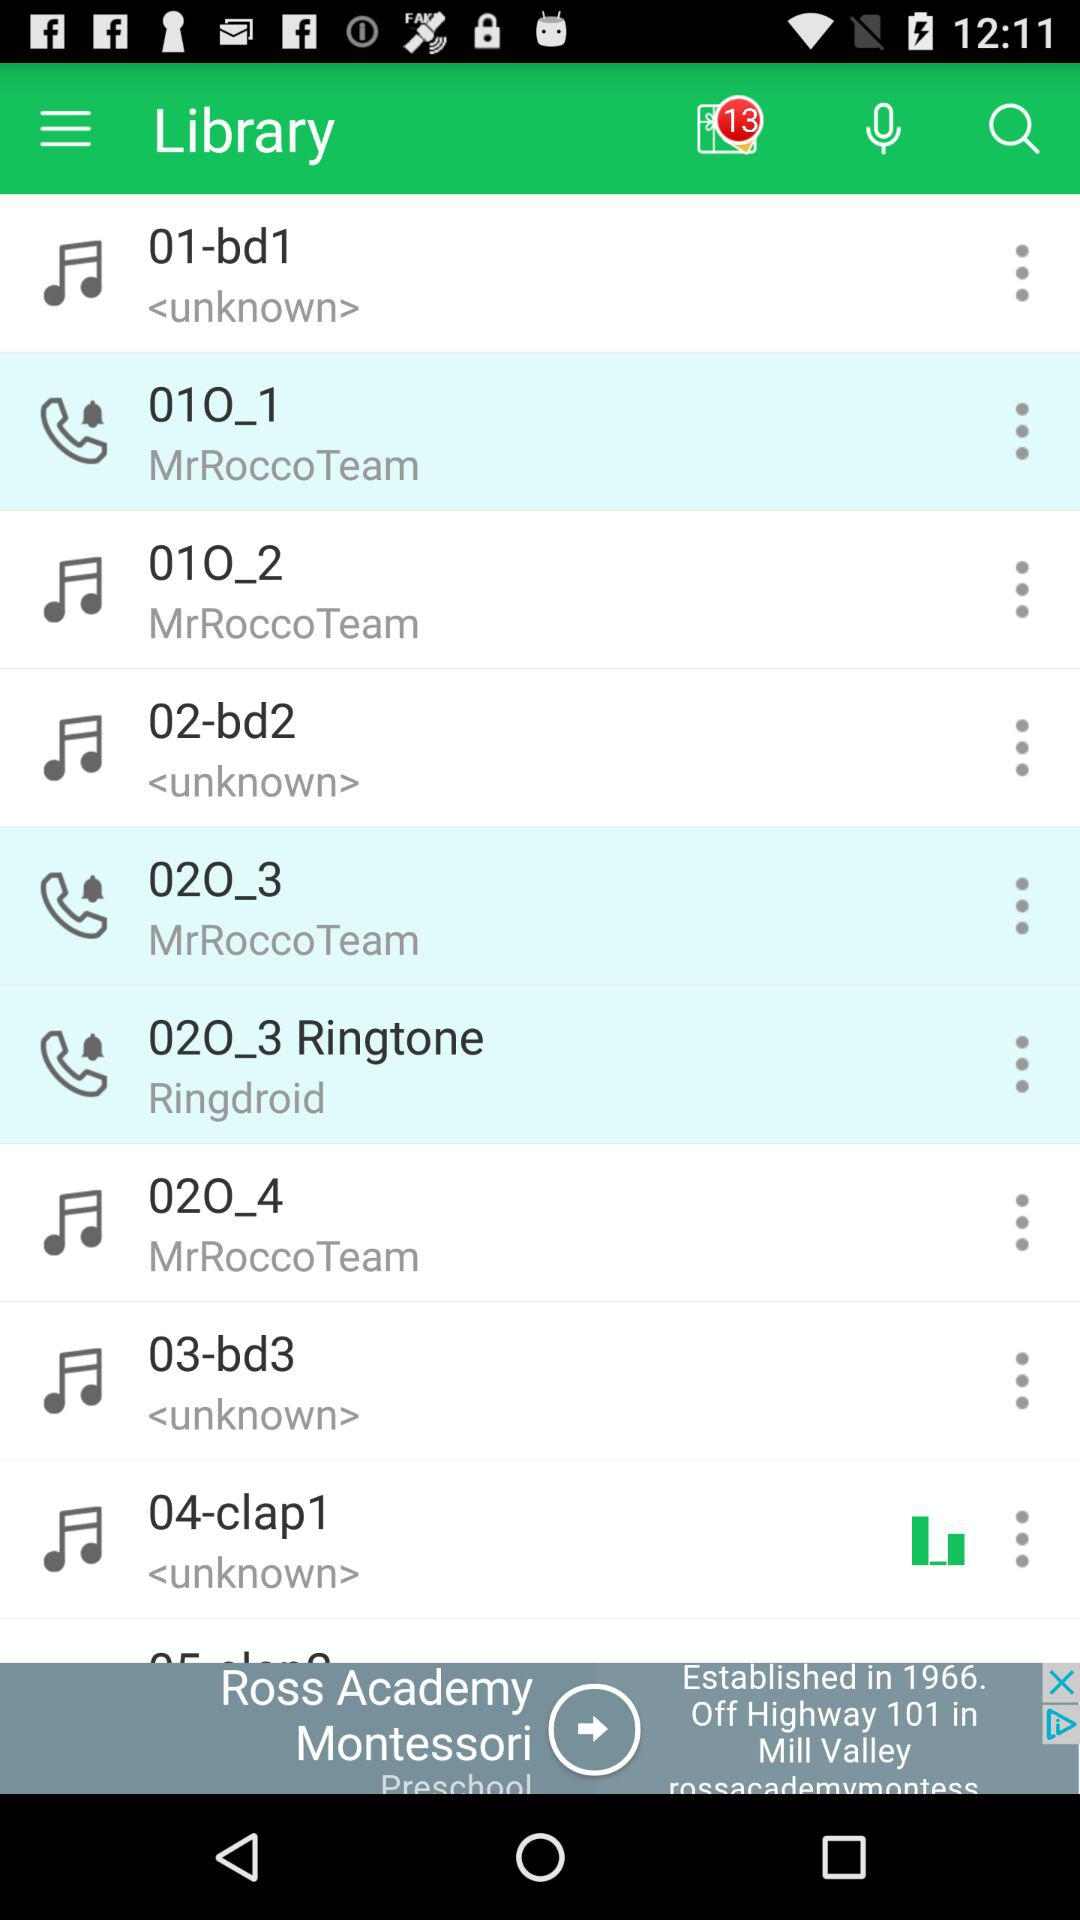How many unread notifications are there? There are 13 unread notifications. 